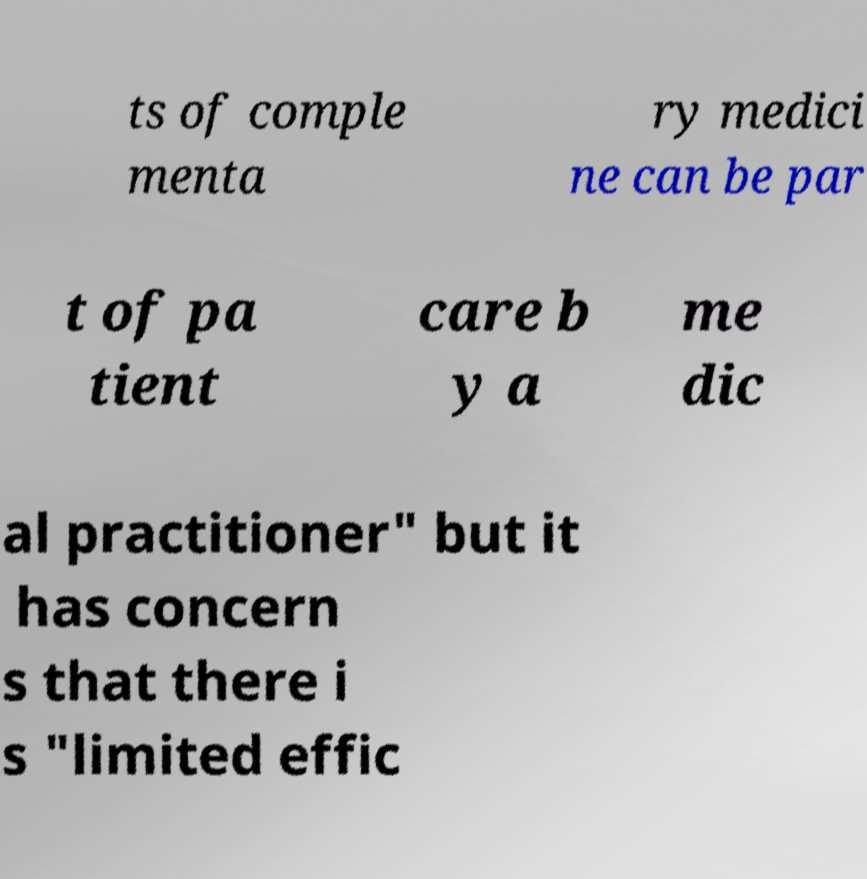I need the written content from this picture converted into text. Can you do that? ts of comple menta ry medici ne can be par t of pa tient care b y a me dic al practitioner" but it has concern s that there i s "limited effic 